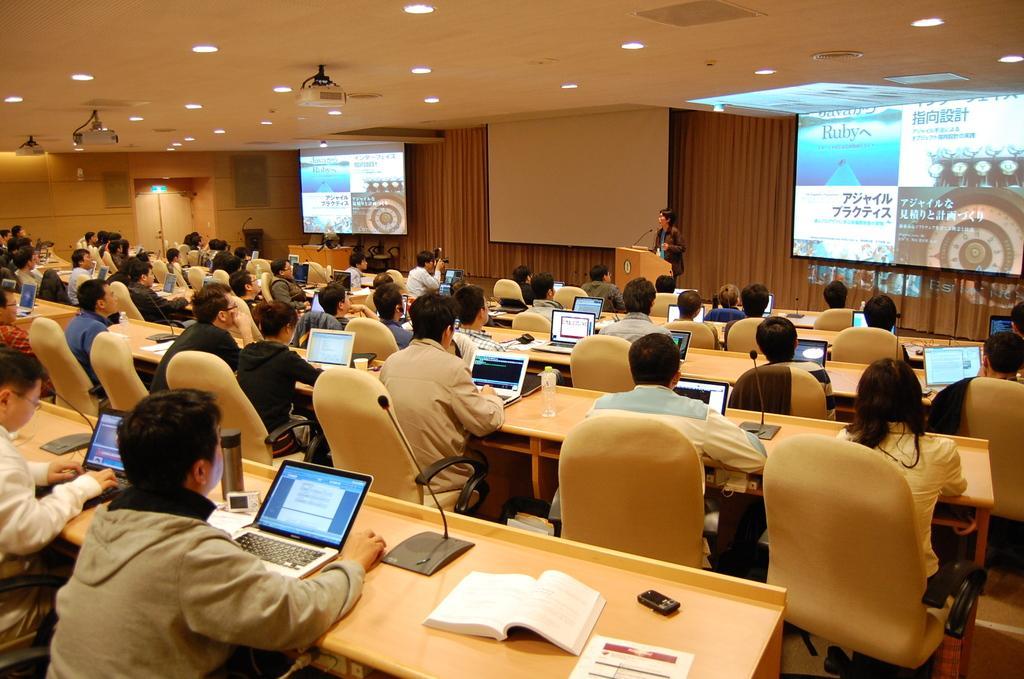How would you summarize this image in a sentence or two? As we can see in the image there is a screen, few people sitting on chairs and there is a table. On table there is a laptop, mic, mobile phone and books. 